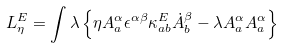<formula> <loc_0><loc_0><loc_500><loc_500>L _ { \eta } ^ { E } = \int \lambda \left \{ \eta A ^ { \alpha } _ { a } \epsilon ^ { \alpha \beta } \kappa _ { a b } ^ { E } \dot { A } ^ { \beta } _ { b } - \lambda A _ { a } ^ { \alpha } A _ { a } ^ { \alpha } \right \}</formula> 